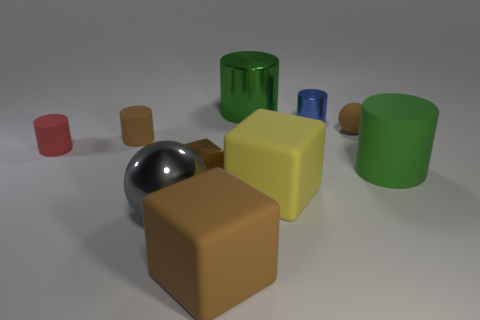There is a tiny blue thing that is the same shape as the green shiny object; what is its material?
Offer a terse response. Metal. There is a red rubber cylinder; does it have the same size as the brown ball behind the large gray metal ball?
Your response must be concise. Yes. What color is the large rubber object on the right side of the tiny brown object that is to the right of the metallic cylinder behind the small blue object?
Ensure brevity in your answer.  Green. Does the big brown object in front of the brown metallic cube have the same material as the large ball?
Your answer should be compact. No. How many other things are there of the same material as the tiny red cylinder?
Provide a succinct answer. 5. What is the material of the brown ball that is the same size as the blue thing?
Ensure brevity in your answer.  Rubber. Is the shape of the small matte thing that is right of the tiny brown metallic block the same as the brown rubber thing left of the big sphere?
Your answer should be compact. No. The other green object that is the same size as the green metal thing is what shape?
Offer a very short reply. Cylinder. Are the ball left of the brown metallic thing and the large green cylinder behind the blue metal thing made of the same material?
Provide a succinct answer. Yes. There is a tiny matte object that is right of the large green shiny cylinder; are there any green cylinders to the right of it?
Your response must be concise. Yes. 